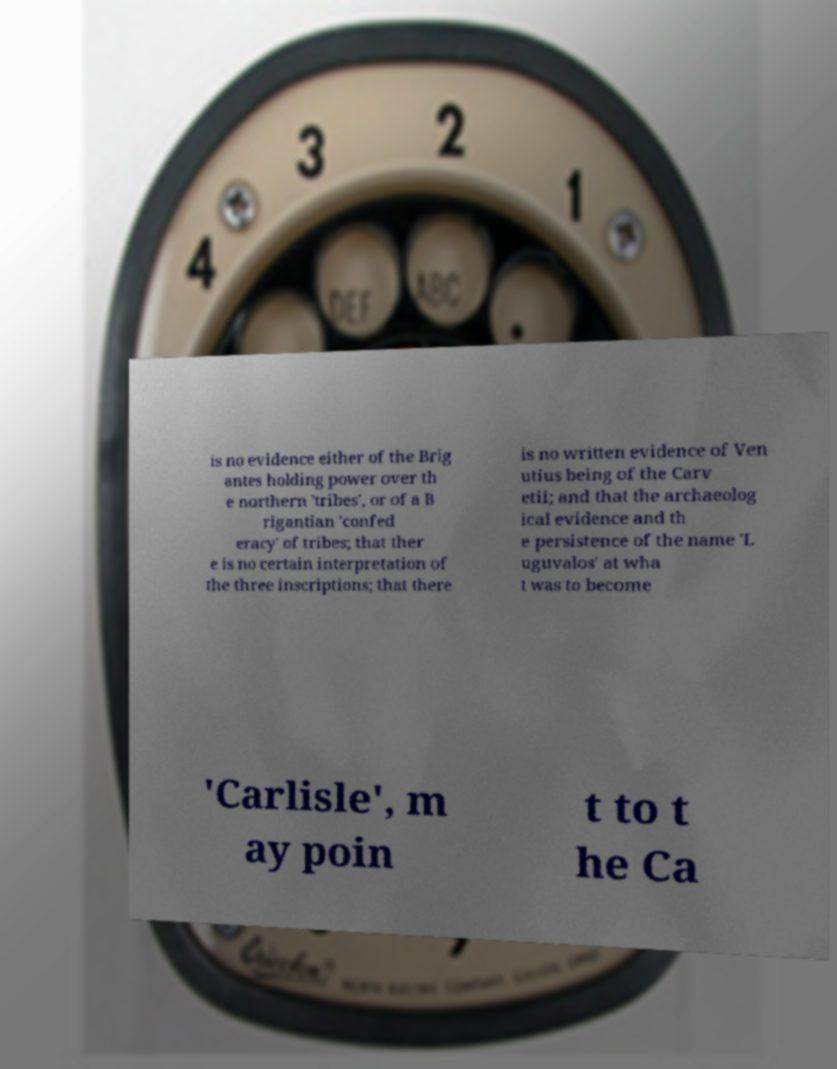Can you accurately transcribe the text from the provided image for me? is no evidence either of the Brig antes holding power over th e northern 'tribes', or of a B rigantian 'confed eracy' of tribes; that ther e is no certain interpretation of the three inscriptions; that there is no written evidence of Ven utius being of the Carv etii; and that the archaeolog ical evidence and th e persistence of the name 'L uguvalos' at wha t was to become 'Carlisle', m ay poin t to t he Ca 